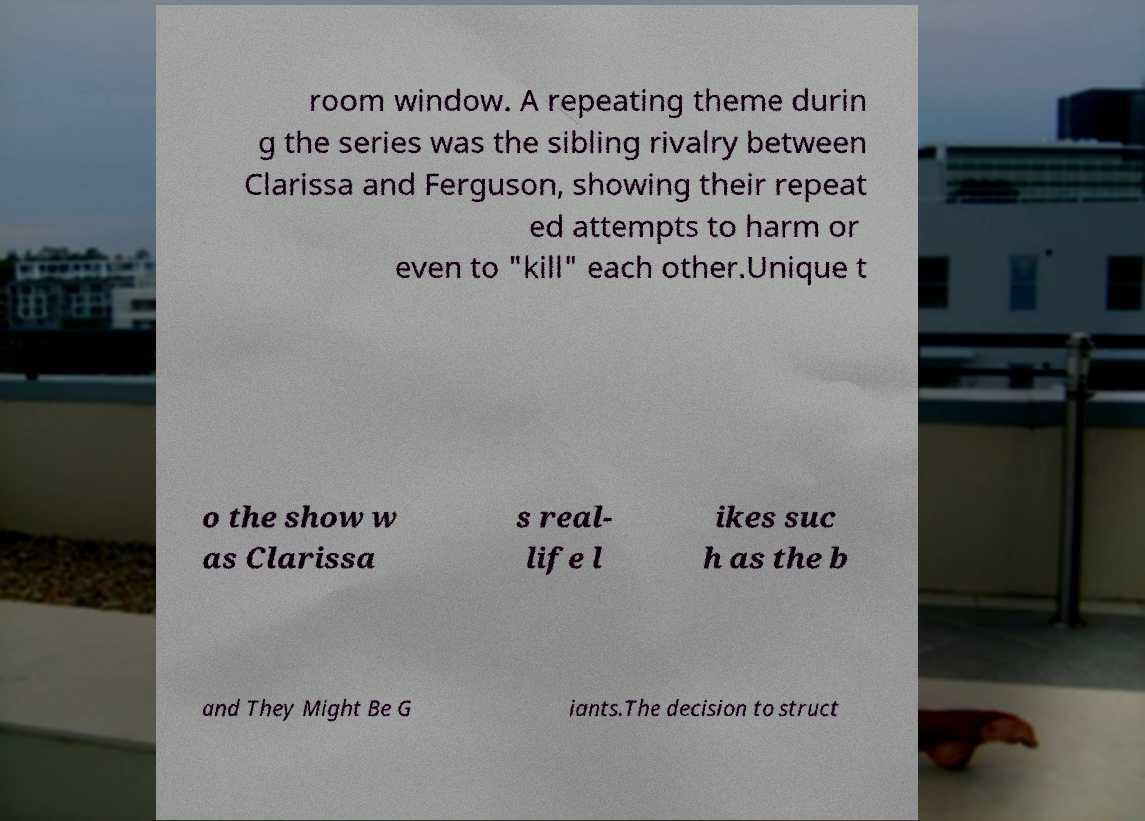Could you extract and type out the text from this image? room window. A repeating theme durin g the series was the sibling rivalry between Clarissa and Ferguson, showing their repeat ed attempts to harm or even to "kill" each other.Unique t o the show w as Clarissa s real- life l ikes suc h as the b and They Might Be G iants.The decision to struct 